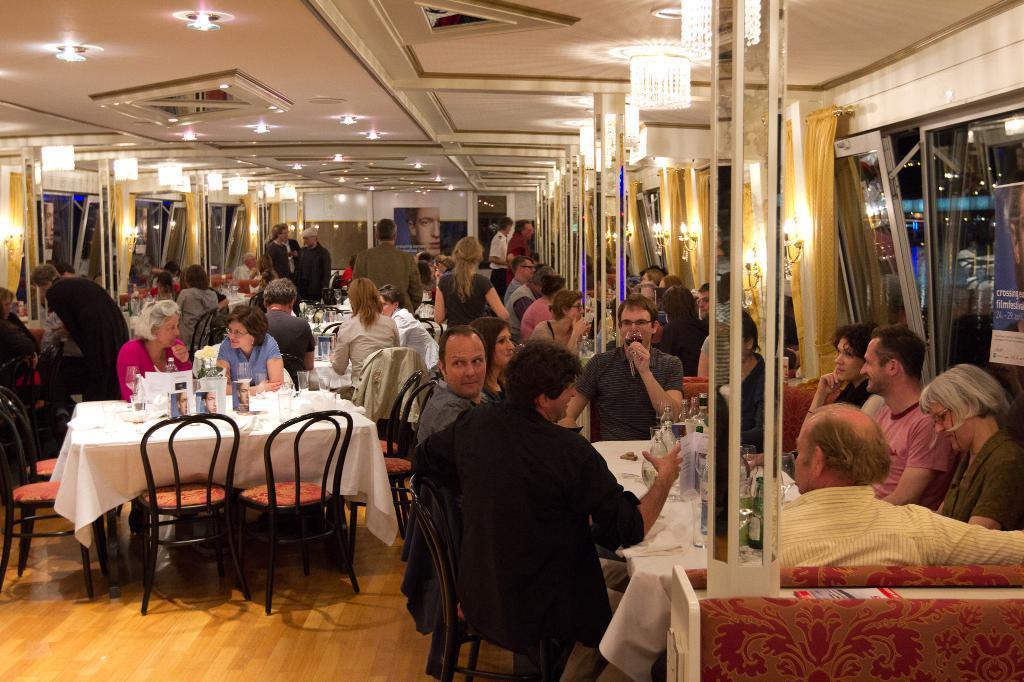In one or two sentences, can you explain what this image depicts? In this image I can see there are group of people among them some are sitting on the chair in front of the white color table and some are standing on the floor. On the table we have some objects on it and the table is covered with white color cloth. Here we have few chairs on the floor. 